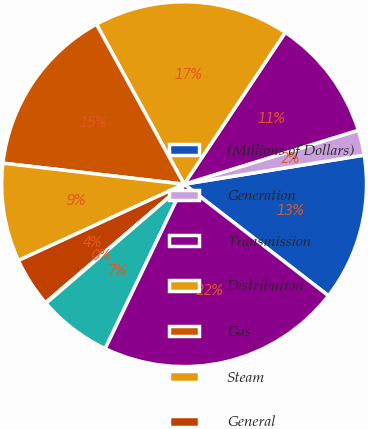Convert chart. <chart><loc_0><loc_0><loc_500><loc_500><pie_chart><fcel>(Millions of Dollars)<fcel>Generation<fcel>Transmission<fcel>Distribution<fcel>Gas<fcel>Steam<fcel>General<fcel>Held for future use<fcel>Construction work in progress<fcel>Net Utility Plant<nl><fcel>13.02%<fcel>2.23%<fcel>10.86%<fcel>17.34%<fcel>15.18%<fcel>8.71%<fcel>4.39%<fcel>0.07%<fcel>6.55%<fcel>21.65%<nl></chart> 